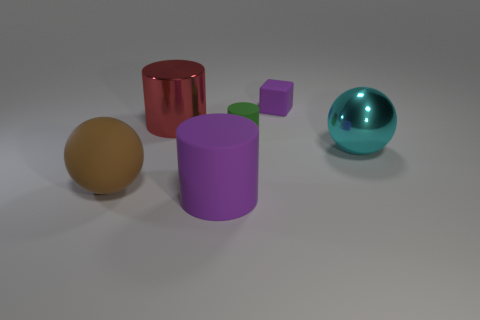Add 1 small blue rubber objects. How many objects exist? 7 Subtract all balls. How many objects are left? 4 Add 5 small green objects. How many small green objects exist? 6 Subtract 1 cyan spheres. How many objects are left? 5 Subtract all blue cylinders. Subtract all cubes. How many objects are left? 5 Add 2 brown matte spheres. How many brown matte spheres are left? 3 